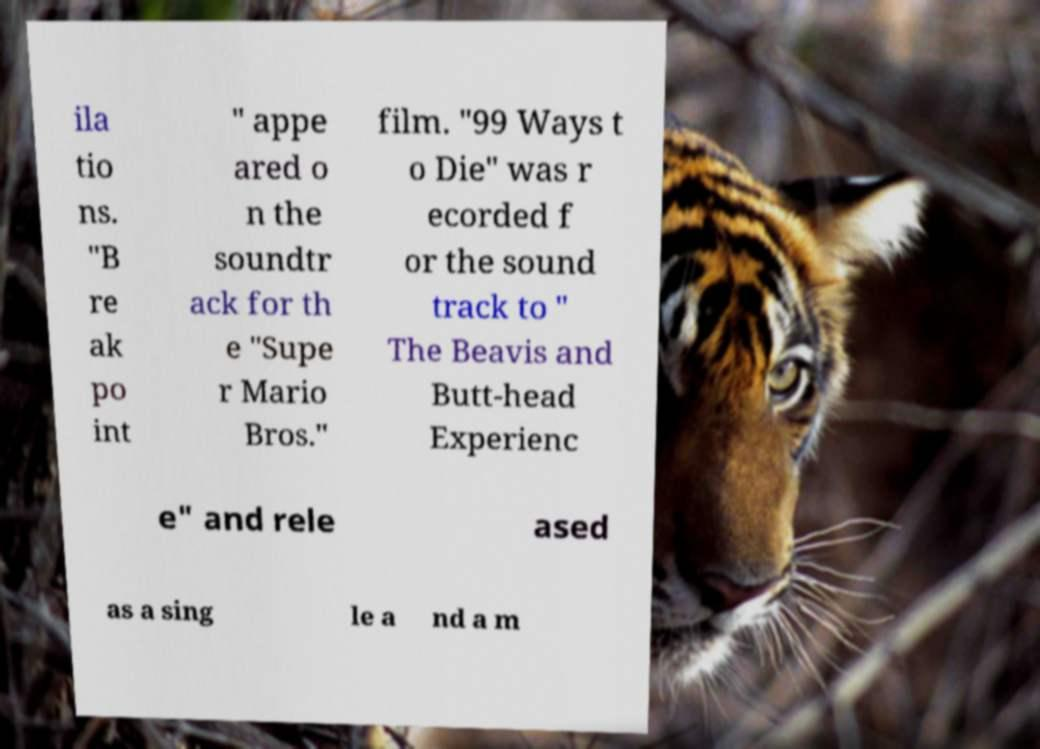Could you assist in decoding the text presented in this image and type it out clearly? ila tio ns. "B re ak po int " appe ared o n the soundtr ack for th e "Supe r Mario Bros." film. "99 Ways t o Die" was r ecorded f or the sound track to " The Beavis and Butt-head Experienc e" and rele ased as a sing le a nd a m 